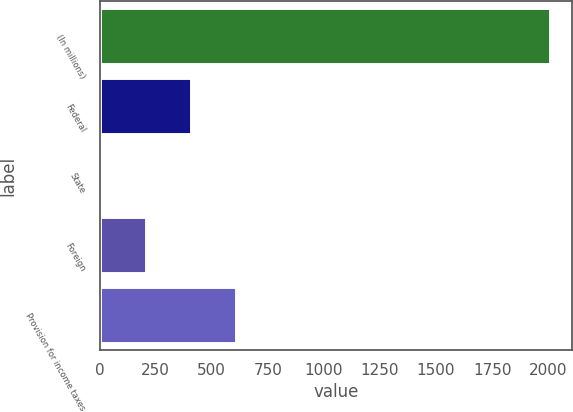Convert chart to OTSL. <chart><loc_0><loc_0><loc_500><loc_500><bar_chart><fcel>(In millions)<fcel>Federal<fcel>State<fcel>Foreign<fcel>Provision for income taxes<nl><fcel>2007<fcel>407.88<fcel>8.1<fcel>207.99<fcel>607.77<nl></chart> 